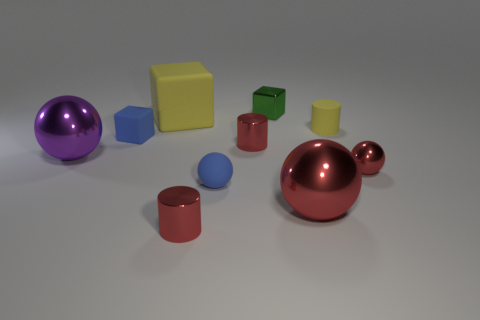There is a metallic cylinder that is behind the large red thing; does it have the same size as the cylinder that is right of the green metal thing?
Provide a short and direct response. Yes. There is a yellow rubber cylinder; are there any large rubber blocks on the right side of it?
Give a very brief answer. No. What is the color of the big shiny sphere right of the block in front of the tiny yellow cylinder?
Your answer should be compact. Red. Is the number of large metal objects less than the number of matte cylinders?
Offer a terse response. No. How many red objects have the same shape as the purple shiny object?
Provide a succinct answer. 2. What is the color of the block that is the same size as the green object?
Ensure brevity in your answer.  Blue. Is the number of matte cylinders that are in front of the tiny blue matte ball the same as the number of rubber cubes behind the green shiny cube?
Offer a very short reply. Yes. Is there another ball of the same size as the purple sphere?
Provide a succinct answer. Yes. The shiny block is what size?
Ensure brevity in your answer.  Small. Is the number of tiny shiny cubes that are in front of the small shiny ball the same as the number of blue balls?
Make the answer very short. No. 